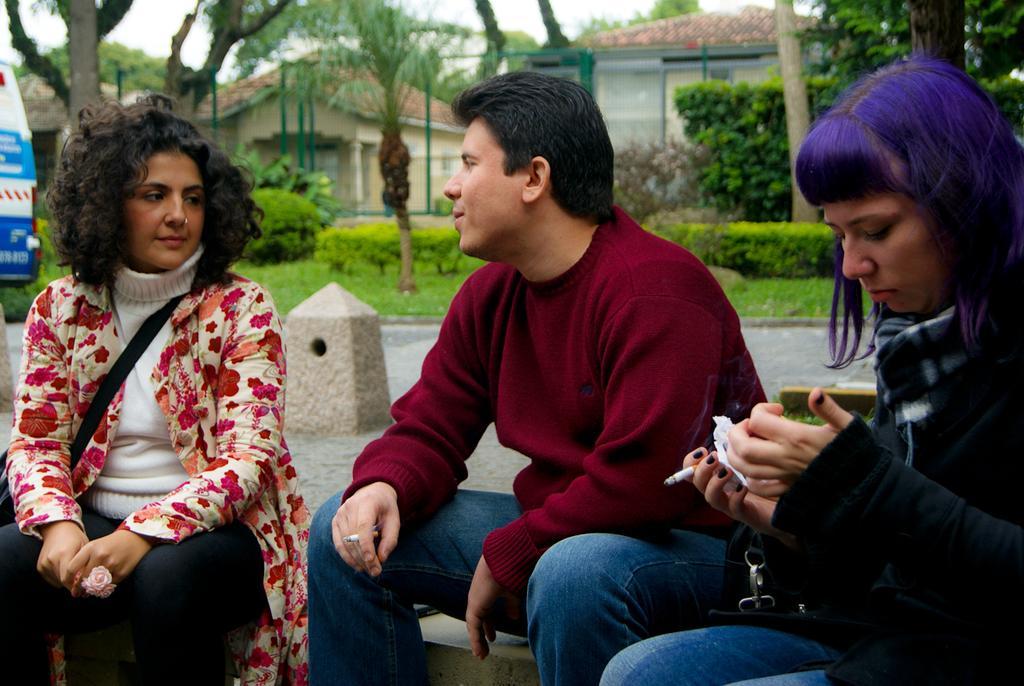How would you summarize this image in a sentence or two? In this image we can see the people sitting on the ground and holding cigarette. In the background, we can see the trees, grass, vehicle, houses, rods and the sky. 